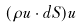Convert formula to latex. <formula><loc_0><loc_0><loc_500><loc_500>( \rho u \cdot d S ) u</formula> 